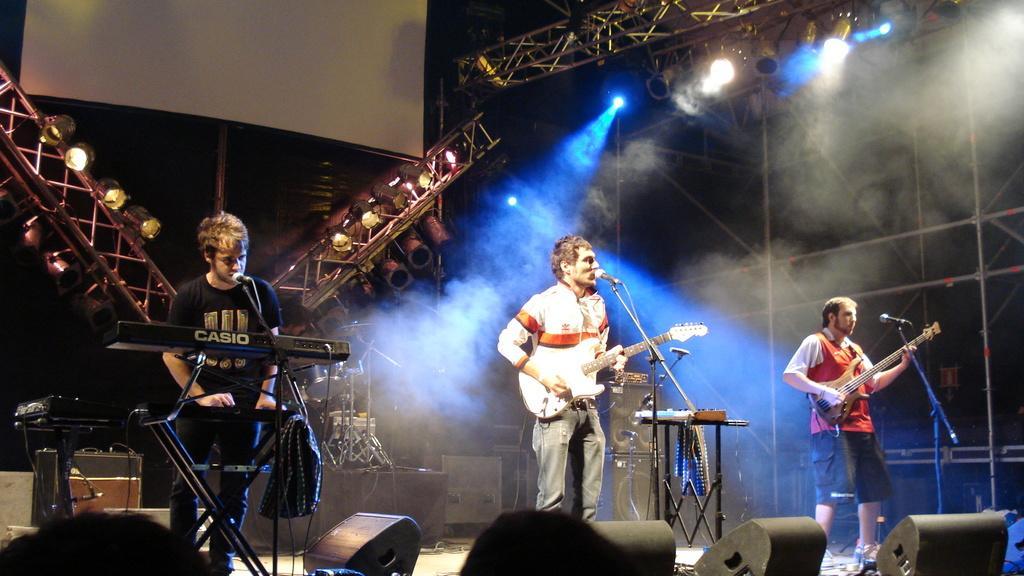In one or two sentences, can you explain what this image depicts? The picture is clicked in a concert and in the background there is screen and stands and lights. In front there are three men standing and performing. The man in the middle singing and playing a guitar. The man to the left is playing a guitar. The man to the left is singing and playing piano. Front below there are speakers. 